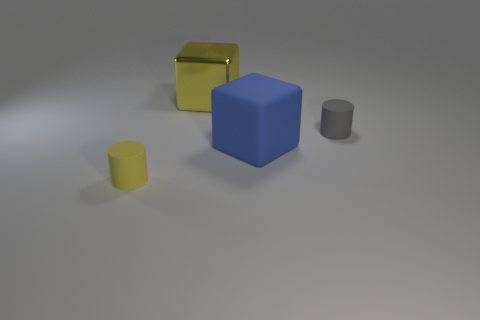How is the lighting arranged in this scene? The lighting in this scene appears to be coming from the upper left, creating soft shadows to the right of the objects, which suggests diffused illumination rather than direct lighting, adding to the objects' three-dimensional appearance. 